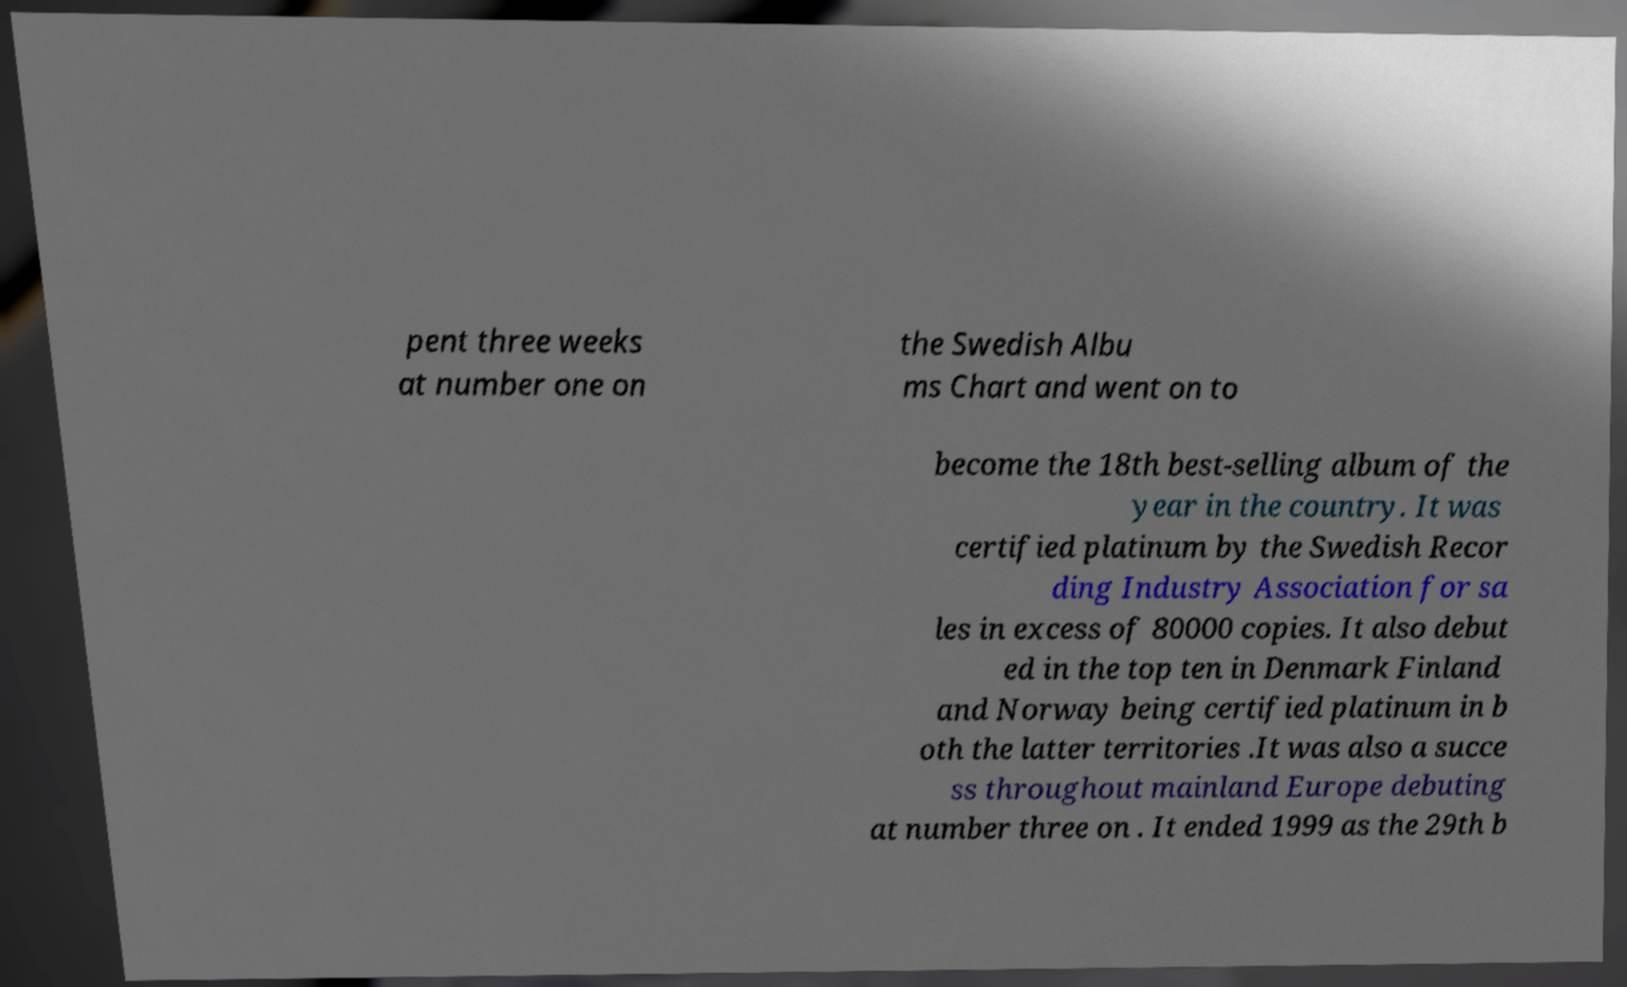Can you read and provide the text displayed in the image?This photo seems to have some interesting text. Can you extract and type it out for me? pent three weeks at number one on the Swedish Albu ms Chart and went on to become the 18th best-selling album of the year in the country. It was certified platinum by the Swedish Recor ding Industry Association for sa les in excess of 80000 copies. It also debut ed in the top ten in Denmark Finland and Norway being certified platinum in b oth the latter territories .It was also a succe ss throughout mainland Europe debuting at number three on . It ended 1999 as the 29th b 